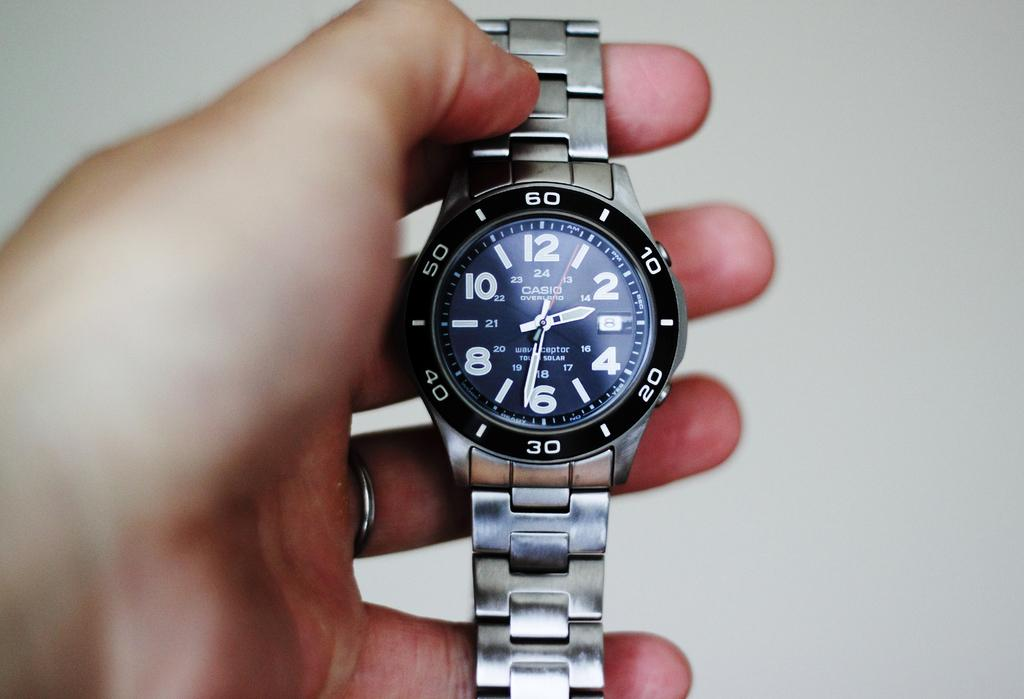Provide a one-sentence caption for the provided image. A person is holding a blue and silver, Casio men's wrist watch that reads the time as 2:31. 